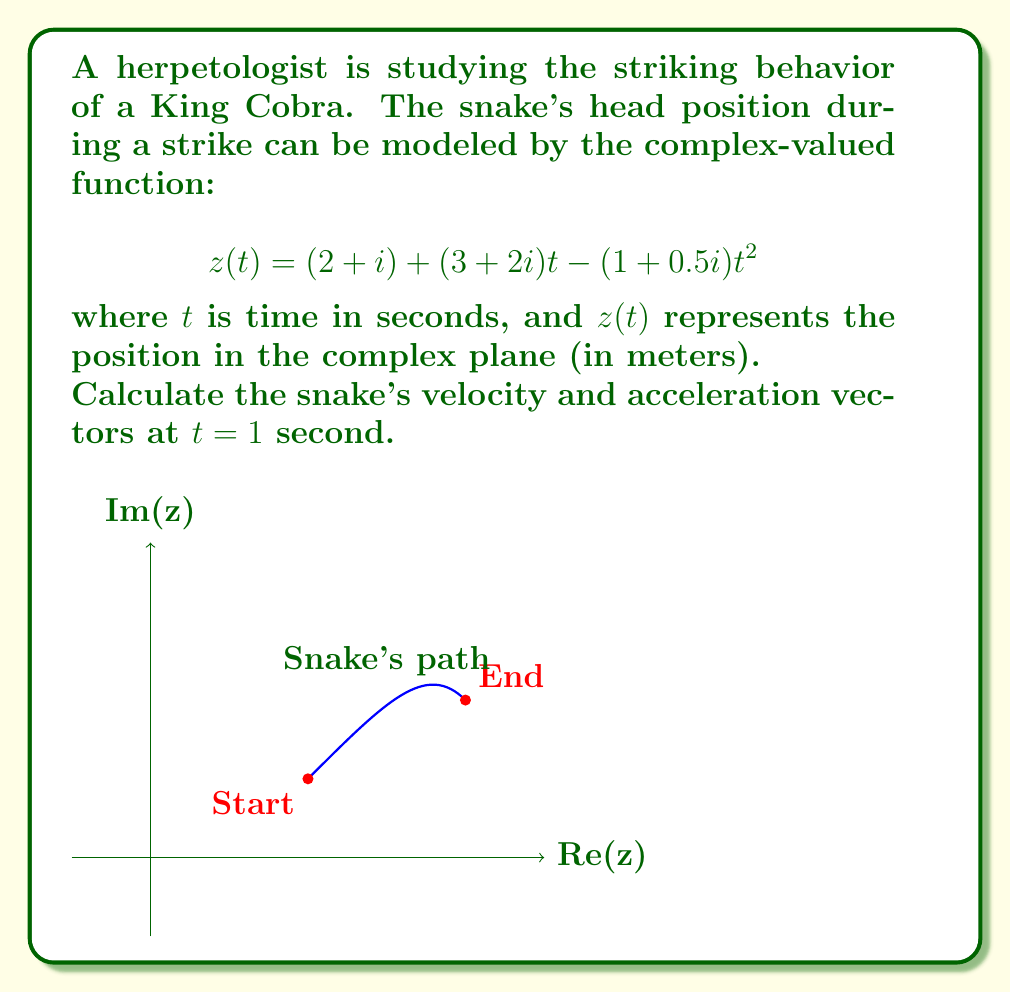Can you answer this question? Let's approach this step-by-step:

1) The position function is given as:
   $$z(t) = (2 + i) + (3 + 2i)t - (1 + 0.5i)t^2$$

2) To find velocity, we need to differentiate $z(t)$ with respect to $t$:
   $$v(t) = z'(t) = (3 + 2i) - 2(1 + 0.5i)t = (3 + 2i) - (2 + i)t$$

3) To find acceleration, we differentiate $v(t)$:
   $$a(t) = v'(t) = -(2 + i)$$

4) Now, let's calculate the velocity at $t = 1$:
   $$v(1) = (3 + 2i) - (2 + i) = 1 + i$$

5) The acceleration is constant:
   $$a = -(2 + i)$$

6) To express these as vectors, we separate the real and imaginary parts:
   Velocity at $t = 1$: $\vec{v} = (1, 1)$ m/s
   Acceleration: $\vec{a} = (-2, -1)$ m/s²

The velocity vector indicates the snake is moving diagonally upward and to the right at 1 m/s in both x and y directions at $t = 1$.
The acceleration vector shows the snake is slowing down and curving its path downward and to the left.
Answer: Velocity at $t = 1$: $\vec{v} = (1, 1)$ m/s
Acceleration: $\vec{a} = (-2, -1)$ m/s² 